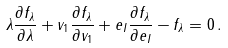<formula> <loc_0><loc_0><loc_500><loc_500>\lambda \frac { \partial f _ { \lambda } } { \partial \lambda } + v _ { 1 } \frac { \partial f _ { \lambda } } { \partial v _ { 1 } } + e _ { I } \frac { \partial f _ { \lambda } } { \partial e _ { I } } - f _ { \lambda } = 0 \, .</formula> 